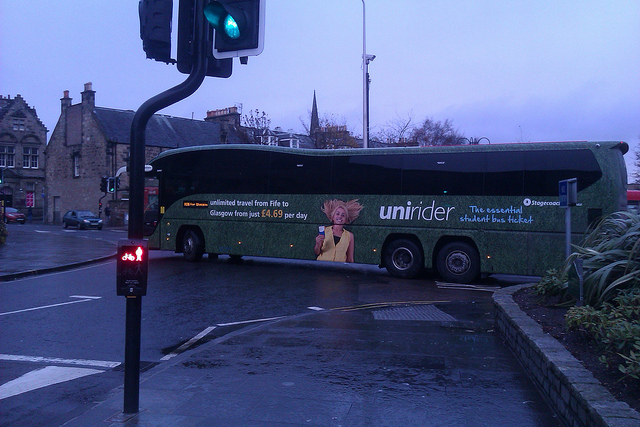Describe the mood or atmosphere conveyed by the image.  The image conveys a slightly overcast and damp atmosphere, suggesting it might have recently rained. The wet pavement and subdued lighting add to a serene, calm urban environment, typical of early mornings or late afternoons. Do the colors of the bus and the environment complement each other? Yes, the colors appear to complement each other well. The green hue of the bus blends harmoniously with the greys and browns of the urban setting, including the stone buildings and the overcast sky, creating a cohesive and visually pleasing scene. 